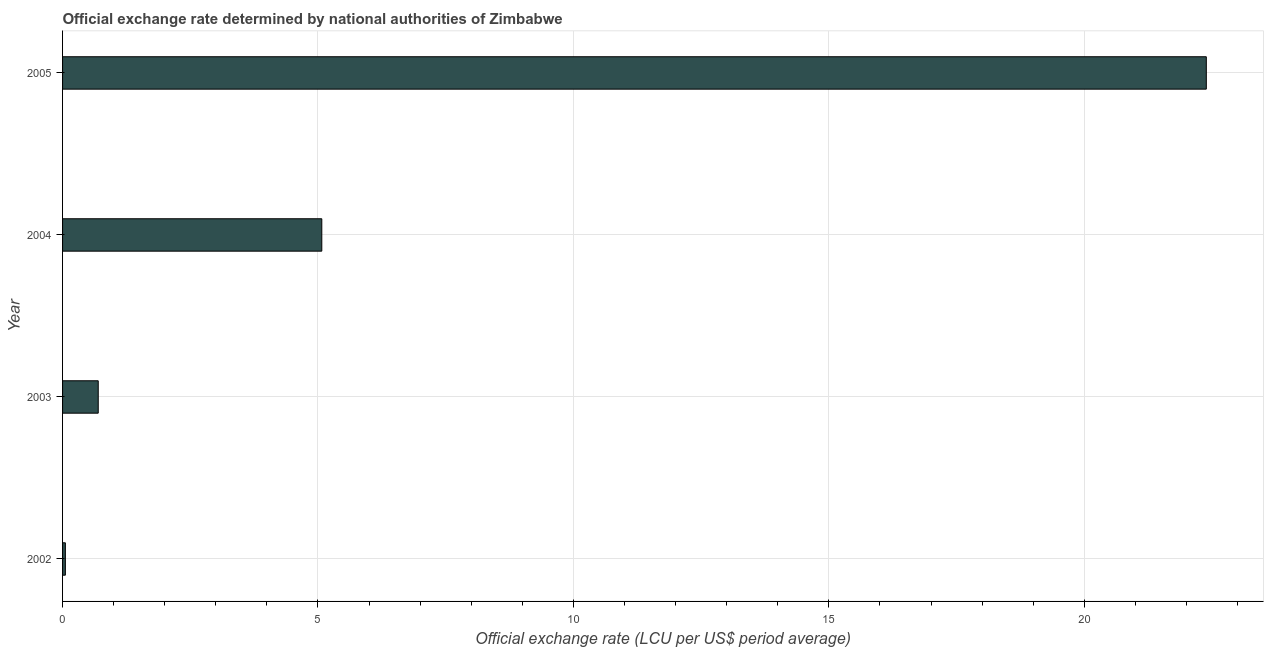What is the title of the graph?
Give a very brief answer. Official exchange rate determined by national authorities of Zimbabwe. What is the label or title of the X-axis?
Make the answer very short. Official exchange rate (LCU per US$ period average). What is the official exchange rate in 2002?
Provide a succinct answer. 0.06. Across all years, what is the maximum official exchange rate?
Provide a succinct answer. 22.39. Across all years, what is the minimum official exchange rate?
Provide a short and direct response. 0.06. In which year was the official exchange rate maximum?
Ensure brevity in your answer.  2005. In which year was the official exchange rate minimum?
Your answer should be very brief. 2002. What is the sum of the official exchange rate?
Provide a short and direct response. 28.22. What is the difference between the official exchange rate in 2002 and 2004?
Provide a succinct answer. -5.02. What is the average official exchange rate per year?
Ensure brevity in your answer.  7.05. What is the median official exchange rate?
Provide a succinct answer. 2.89. In how many years, is the official exchange rate greater than 6 ?
Your response must be concise. 1. What is the ratio of the official exchange rate in 2002 to that in 2005?
Offer a terse response. 0. Is the official exchange rate in 2003 less than that in 2005?
Give a very brief answer. Yes. What is the difference between the highest and the second highest official exchange rate?
Offer a very short reply. 17.32. What is the difference between the highest and the lowest official exchange rate?
Offer a terse response. 22.33. How many bars are there?
Provide a succinct answer. 4. Are all the bars in the graph horizontal?
Your response must be concise. Yes. What is the Official exchange rate (LCU per US$ period average) in 2002?
Provide a succinct answer. 0.06. What is the Official exchange rate (LCU per US$ period average) of 2003?
Your response must be concise. 0.7. What is the Official exchange rate (LCU per US$ period average) of 2004?
Offer a very short reply. 5.07. What is the Official exchange rate (LCU per US$ period average) in 2005?
Your response must be concise. 22.39. What is the difference between the Official exchange rate (LCU per US$ period average) in 2002 and 2003?
Ensure brevity in your answer.  -0.64. What is the difference between the Official exchange rate (LCU per US$ period average) in 2002 and 2004?
Your answer should be compact. -5.02. What is the difference between the Official exchange rate (LCU per US$ period average) in 2002 and 2005?
Keep it short and to the point. -22.33. What is the difference between the Official exchange rate (LCU per US$ period average) in 2003 and 2004?
Your answer should be compact. -4.38. What is the difference between the Official exchange rate (LCU per US$ period average) in 2003 and 2005?
Keep it short and to the point. -21.69. What is the difference between the Official exchange rate (LCU per US$ period average) in 2004 and 2005?
Provide a short and direct response. -17.31. What is the ratio of the Official exchange rate (LCU per US$ period average) in 2002 to that in 2003?
Your answer should be compact. 0.08. What is the ratio of the Official exchange rate (LCU per US$ period average) in 2002 to that in 2004?
Offer a very short reply. 0.01. What is the ratio of the Official exchange rate (LCU per US$ period average) in 2002 to that in 2005?
Ensure brevity in your answer.  0. What is the ratio of the Official exchange rate (LCU per US$ period average) in 2003 to that in 2004?
Your response must be concise. 0.14. What is the ratio of the Official exchange rate (LCU per US$ period average) in 2003 to that in 2005?
Give a very brief answer. 0.03. What is the ratio of the Official exchange rate (LCU per US$ period average) in 2004 to that in 2005?
Your answer should be compact. 0.23. 